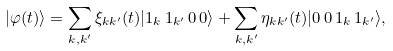<formula> <loc_0><loc_0><loc_500><loc_500>| \varphi ( t ) \rangle = \sum _ { k , k ^ { \prime } } \xi _ { k k ^ { \prime } } ( t ) | 1 _ { k } \, 1 _ { k ^ { \prime } } \, 0 \, 0 \rangle + \sum _ { k , k ^ { \prime } } \eta _ { k k ^ { \prime } } ( t ) | 0 \, 0 \, 1 _ { k } \, 1 _ { k ^ { \prime } } \rangle ,</formula> 